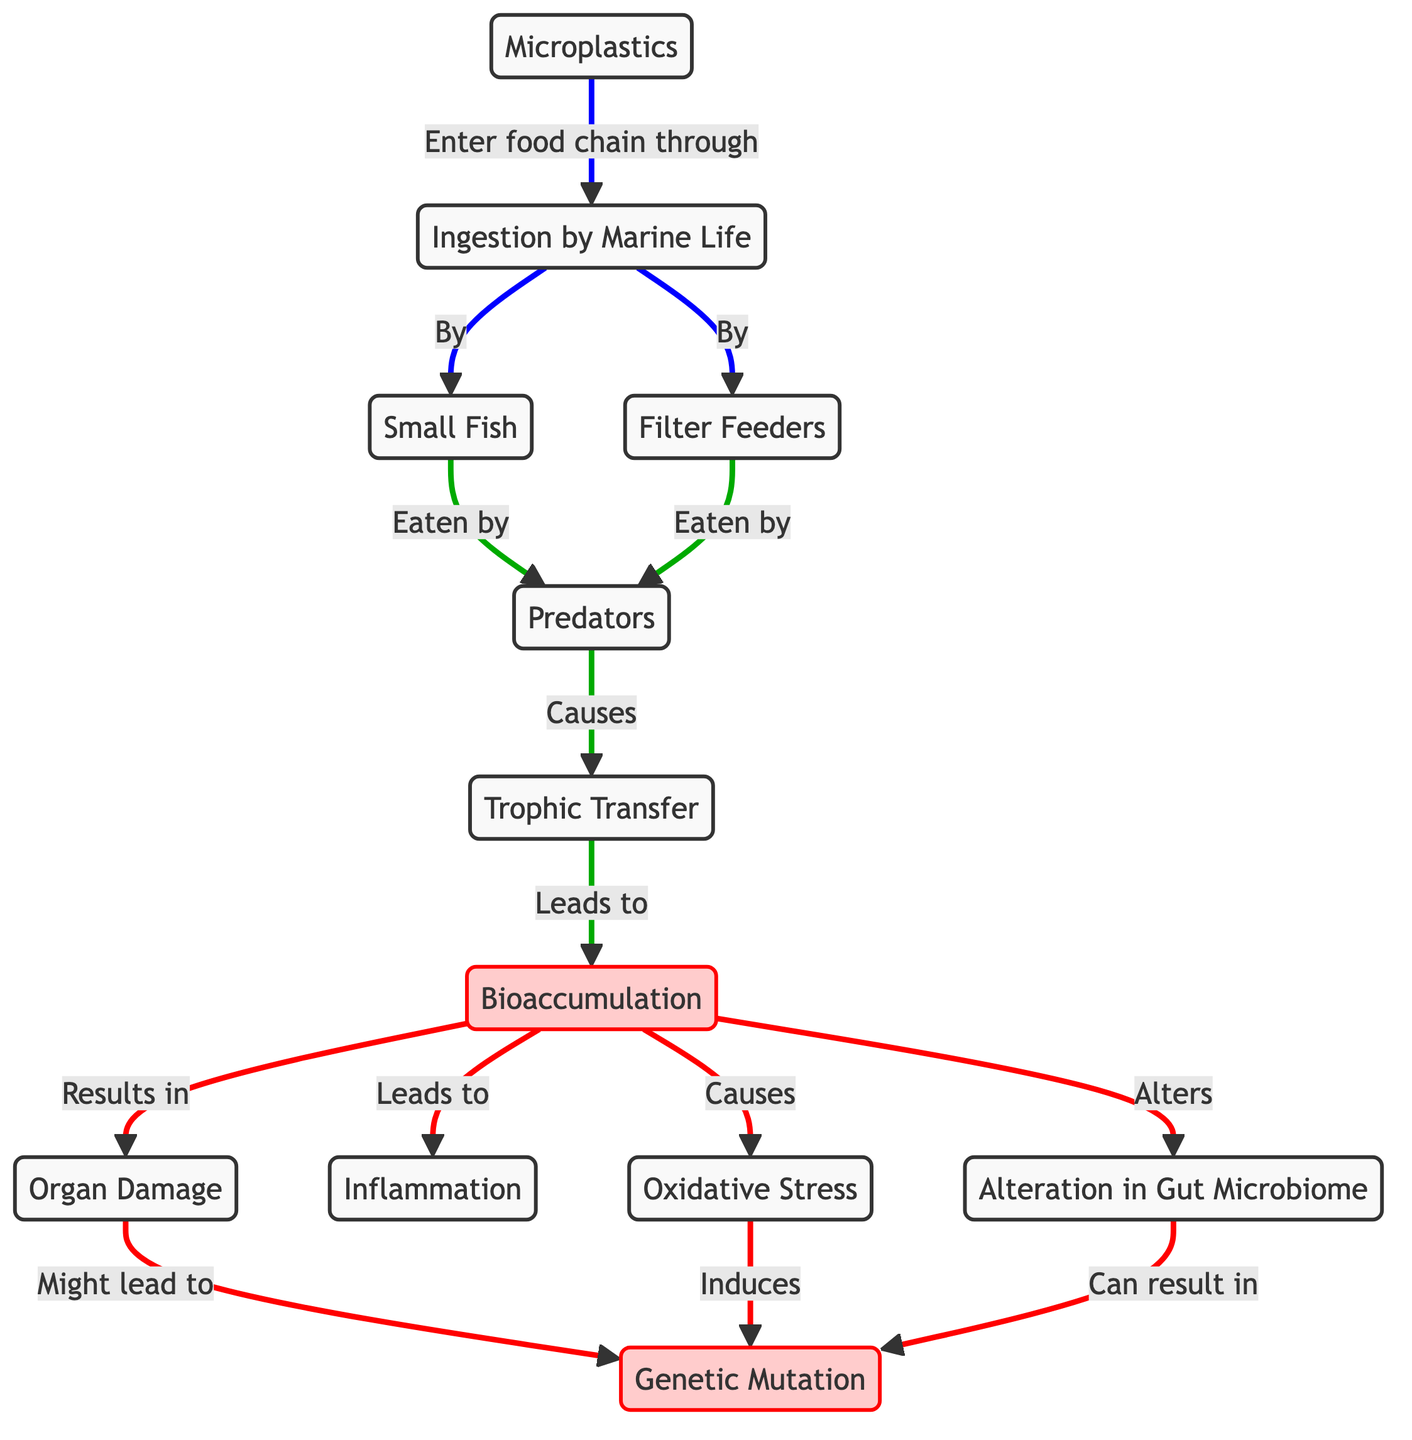What is the first step in the pathway of microplastics? The first step in the pathway is the ingestion of microplastics by marine life, indicated in the diagram.
Answer: Ingestion by Marine Life How do filter feeders interact with microplastics? Filter feeders ingest microplastics as part of their feeding process, which is depicted in the diagram.
Answer: By filter feeders How many types of marine life are mentioned in the diagram? The diagram mentions three types of marine life: filter feeders, small fish, and predators.
Answer: Three Which process leads to organ damage? Organ damage results from the accumulation of microplastics in organisms, as shown in the diagram.
Answer: Accumulation What does oxidative stress induce? According to the diagram, oxidative stress induces genetic mutation as a consequence of microplastic accumulation.
Answer: Genetic Mutation What is altered by bioaccumulation? The alteration in gut microbiome is a result of bioaccumulation of microplastics, as stated in the diagram.
Answer: Gut Microbiome What is the relationship between small fish and predators? Small fish are eaten by predators, indicating a direct predator-prey relationship in the flow of microplastics.
Answer: Eaten by How does trophic transfer relate to microplastics? Trophic transfer occurs as predators consume filter feeders and small fish that have ingested microplastics, leading to higher levels of microplastics at higher trophic levels.
Answer: Causes Which impact is suggested to have a direct link to organ damage? The diagram suggests that organ damage might lead to genetic mutation, highlighting a potential severe impact of microplastics on marine life.
Answer: Genetic Mutation What type of diagram does the flowchart represent? The flowchart represents a biomedical diagram, which details the impact of microplastics on marine biodiversity and genetic mutations.
Answer: Biomedical Diagram 